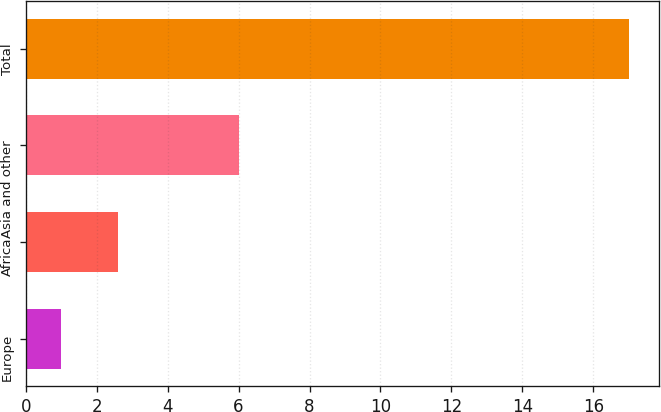Convert chart to OTSL. <chart><loc_0><loc_0><loc_500><loc_500><bar_chart><fcel>Europe<fcel>Africa<fcel>Asia and other<fcel>Total<nl><fcel>1<fcel>2.6<fcel>6<fcel>17<nl></chart> 